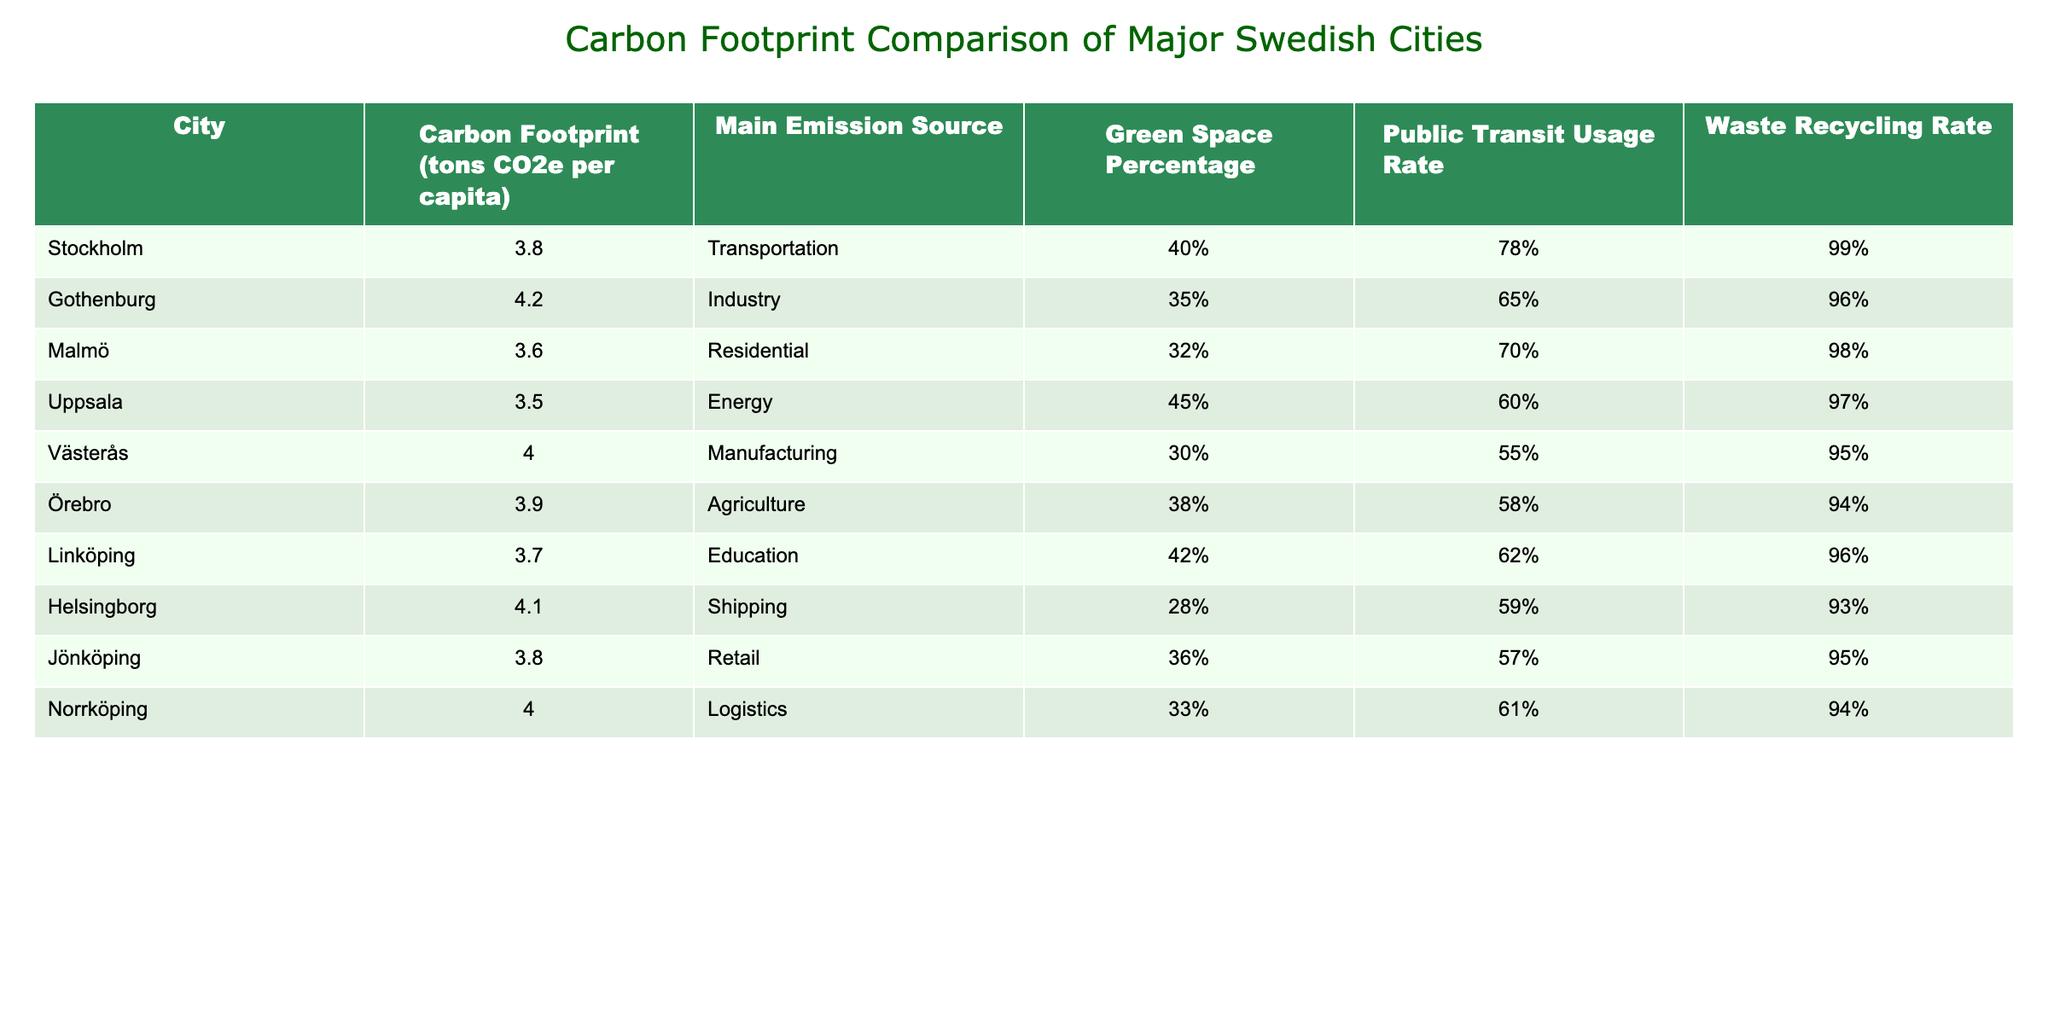What is the carbon footprint per capita in Stockholm? By looking at the table, the value corresponding to Stockholm in the "Carbon Footprint (tons CO2e per capita)" column is 3.8.
Answer: 3.8 Which city has the highest carbon footprint per capita? The city with the highest carbon footprint is Gothenburg, with a value of 4.2 tons CO2e per capita, as noted in the table.
Answer: Gothenburg What is the public transit usage rate in Malmö? The table shows that the public transit usage rate for Malmö is 70%.
Answer: 70% How do the carbon footprints of Uppsala and Västerås compare? Uppsala has a carbon footprint of 3.5 tons CO2e per capita, while Västerås has a footprint of 4.0 tons. Thus, Västerås has a higher footprint by 0.5 tons.
Answer: Västerås has a higher footprint by 0.5 tons What is the average carbon footprint of all the cities listed? To find the average, sum the carbon footprints of all cities (3.8 + 4.2 + 3.6 + 3.5 + 4.0 + 3.9 + 3.7 + 4.1 + 3.8 + 4.0) resulting in 40.6 tons, and then divide by the number of cities (10). The average is 40.6 / 10 = 4.06 tons CO2e.
Answer: 4.06 Does Göteborg have a greater waste recycling rate than Helsingborg? Göteborg has a waste recycling rate of 96%, while Helsingborg's rate is 93%. Thus, Göteborg does have a greater recycling rate than Helsingborg.
Answer: Yes Which city has the highest green space percentage and what is that percentage? Uppsala has the highest green space percentage at 45%, as you can see in the respective column in the table.
Answer: 45% What is the relationship between public transit usage and carbon footprint for these cities? By analyzing the table, we can see that cities with higher public transit usage rates (like Stockholm at 78% and Malmö at 70%) tend to have lower carbon footprints compared to others such as Gothenburg at 4.2 tons CO2e and a 65% usage rate. This suggests a possible inverse relationship.
Answer: Inverse relationship suggested Identify the city with the lowest waste recycling rate and its value. The city with the lowest waste recycling rate is Helsingborg, with a rate of 93%, according to the table.
Answer: Helsingborg, 93% How much higher is the carbon footprint of Gothenburg compared to Uppsala? Gothenburg's carbon footprint is 4.2 tons, while Uppsala's is 3.5 tons. The difference is 4.2 - 3.5 = 0.7 tons, indicating Gothenburg's footprint is higher by that margin.
Answer: 0.7 tons Are any cities above the average carbon footprint of the listed cities? The average carbon footprint of the listed cities is 4.06 tons CO2e. Gothenburg (4.2 tons) and Västerås (4.0 tons) are both above this average, as indicated in the table.
Answer: Yes, Gothenburg and Västerås are above the average 